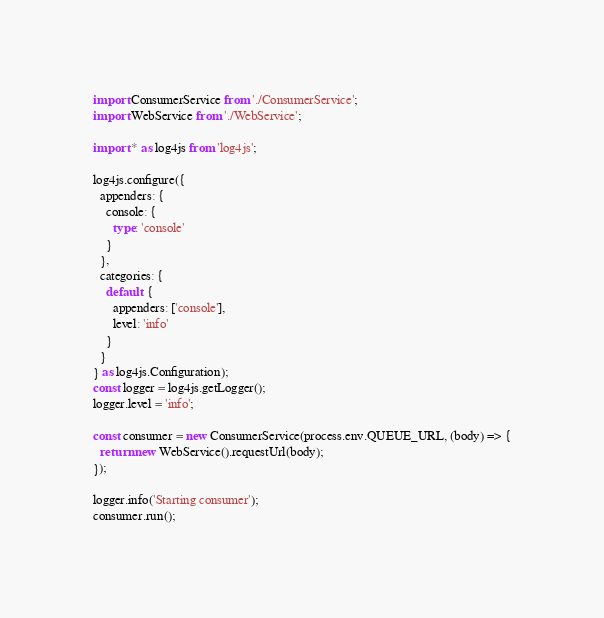<code> <loc_0><loc_0><loc_500><loc_500><_TypeScript_>import ConsumerService from './ConsumerService';
import WebService from './WebService';

import * as log4js from 'log4js';

log4js.configure({
  appenders: {
    console: {
      type: 'console'
    }
  },
  categories: {
    default: {
      appenders: ['console'],
      level: 'info'
    }
  }
} as log4js.Configuration);
const logger = log4js.getLogger();
logger.level = 'info';

const consumer = new ConsumerService(process.env.QUEUE_URL, (body) => {
  return new WebService().requestUrl(body);
});

logger.info('Starting consumer');
consumer.run();
</code> 